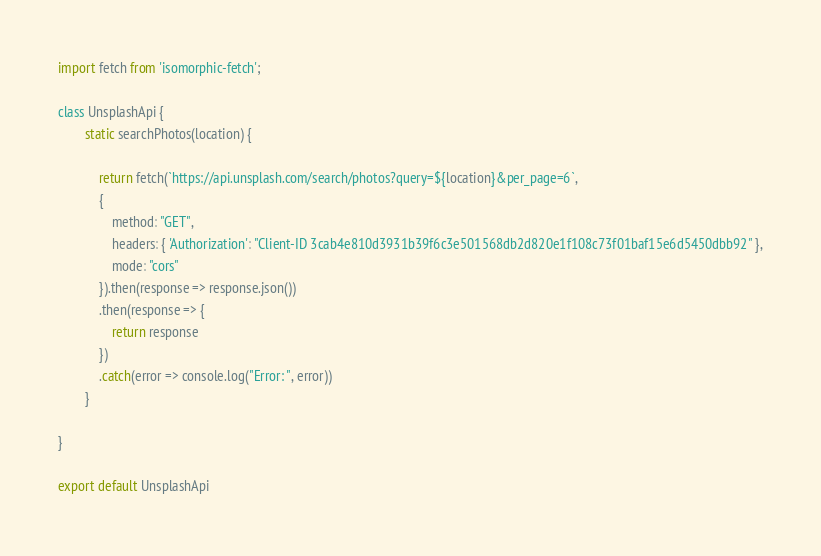<code> <loc_0><loc_0><loc_500><loc_500><_JavaScript_>import fetch from 'isomorphic-fetch';

class UnsplashApi {
        static searchPhotos(location) {

            return fetch(`https://api.unsplash.com/search/photos?query=${location}&per_page=6`,
            {
                method: "GET",
                headers: { 'Authorization': "Client-ID 3cab4e810d3931b39f6c3e501568db2d820e1f108c73f01baf15e6d5450dbb92" },
                mode: "cors"
            }).then(response => response.json())
            .then(response => {
                return response
            })
            .catch(error => console.log("Error: ", error))
        }

}

export default UnsplashApi</code> 